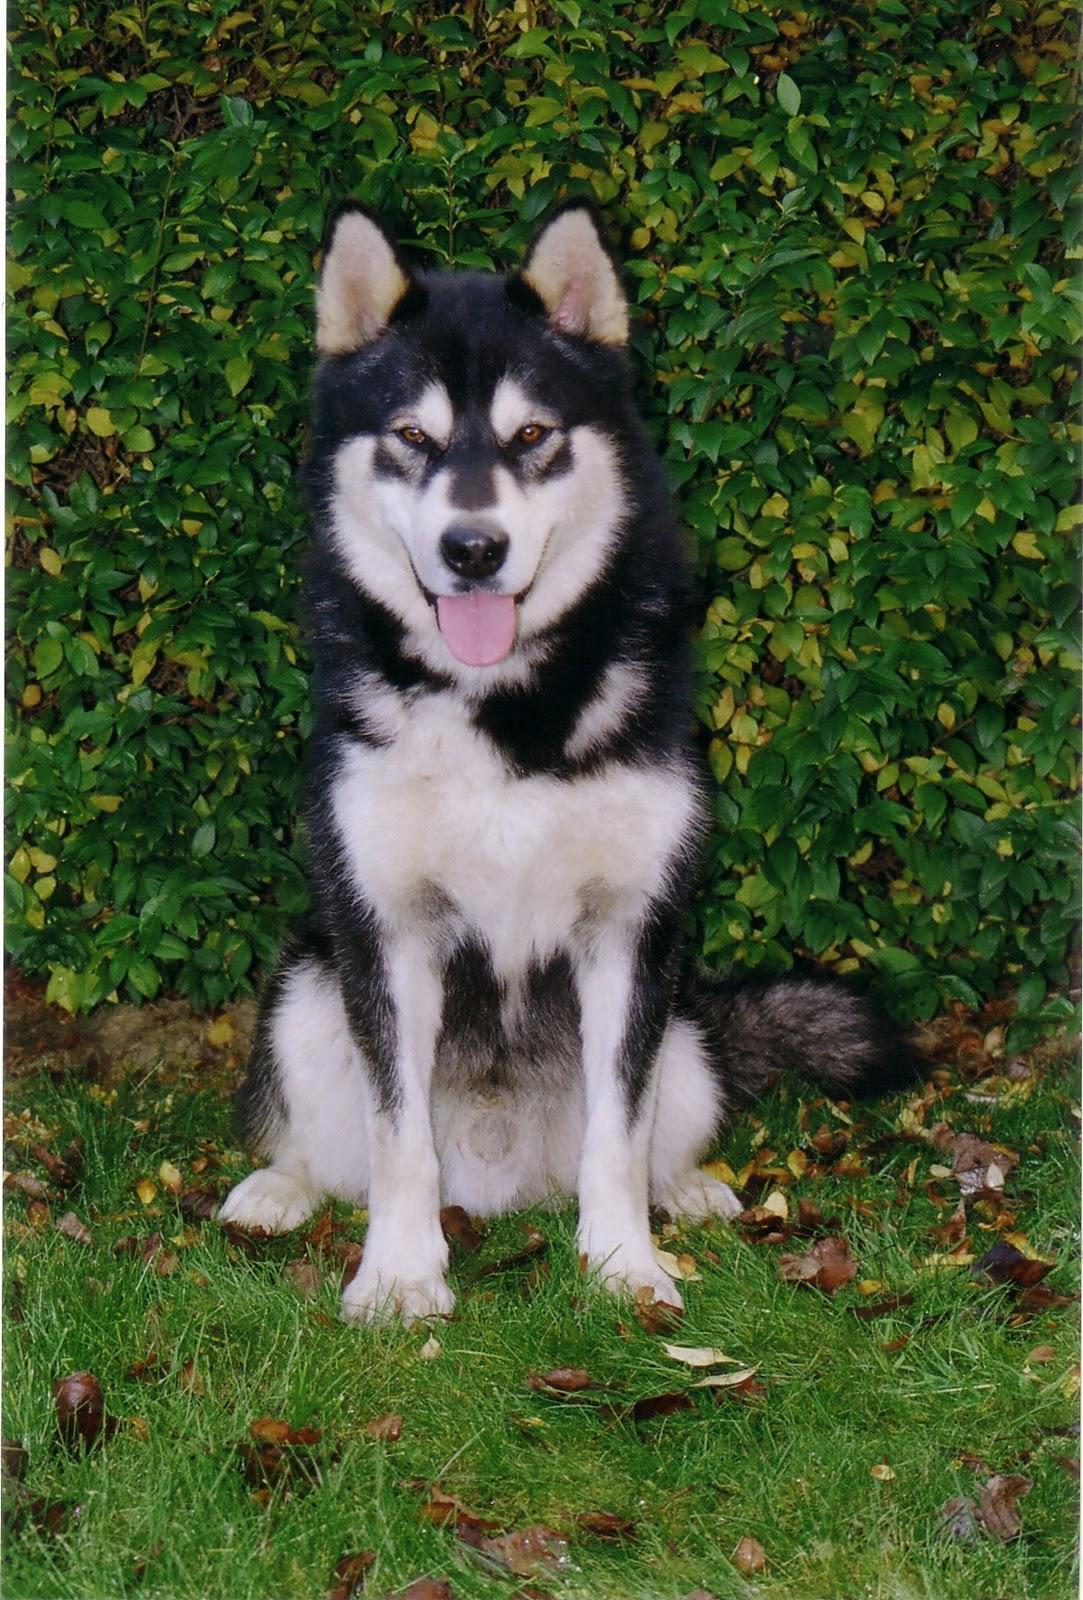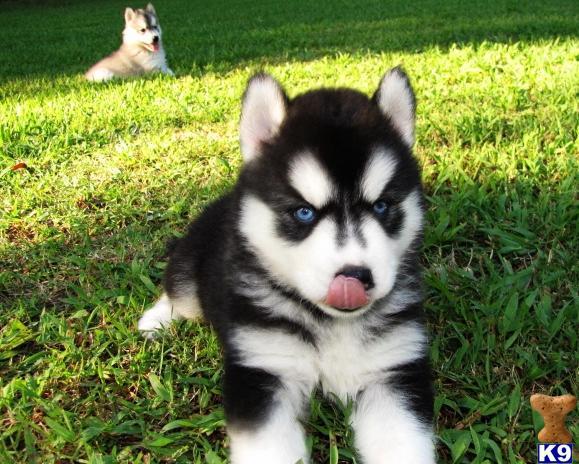The first image is the image on the left, the second image is the image on the right. Examine the images to the left and right. Is the description "Each image contains one forward-facing husky in the foreground, at least one dog has blue eyes, and one dog sits upright on green grass." accurate? Answer yes or no. Yes. The first image is the image on the left, the second image is the image on the right. Analyze the images presented: Is the assertion "A dog is sitting in the grass in the image on the left." valid? Answer yes or no. Yes. 